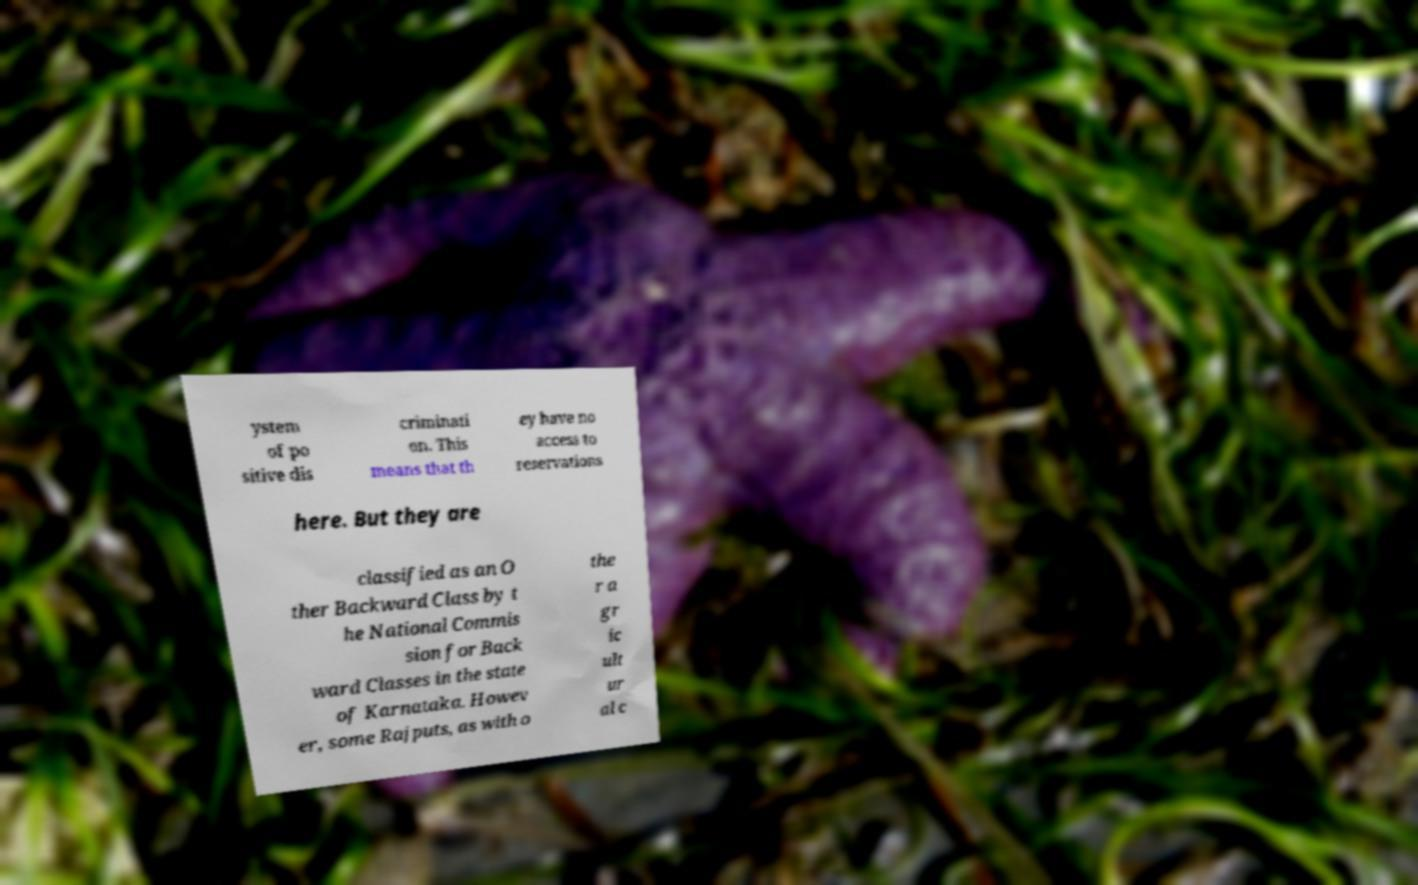Can you accurately transcribe the text from the provided image for me? ystem of po sitive dis criminati on. This means that th ey have no access to reservations here. But they are classified as an O ther Backward Class by t he National Commis sion for Back ward Classes in the state of Karnataka. Howev er, some Rajputs, as with o the r a gr ic ult ur al c 